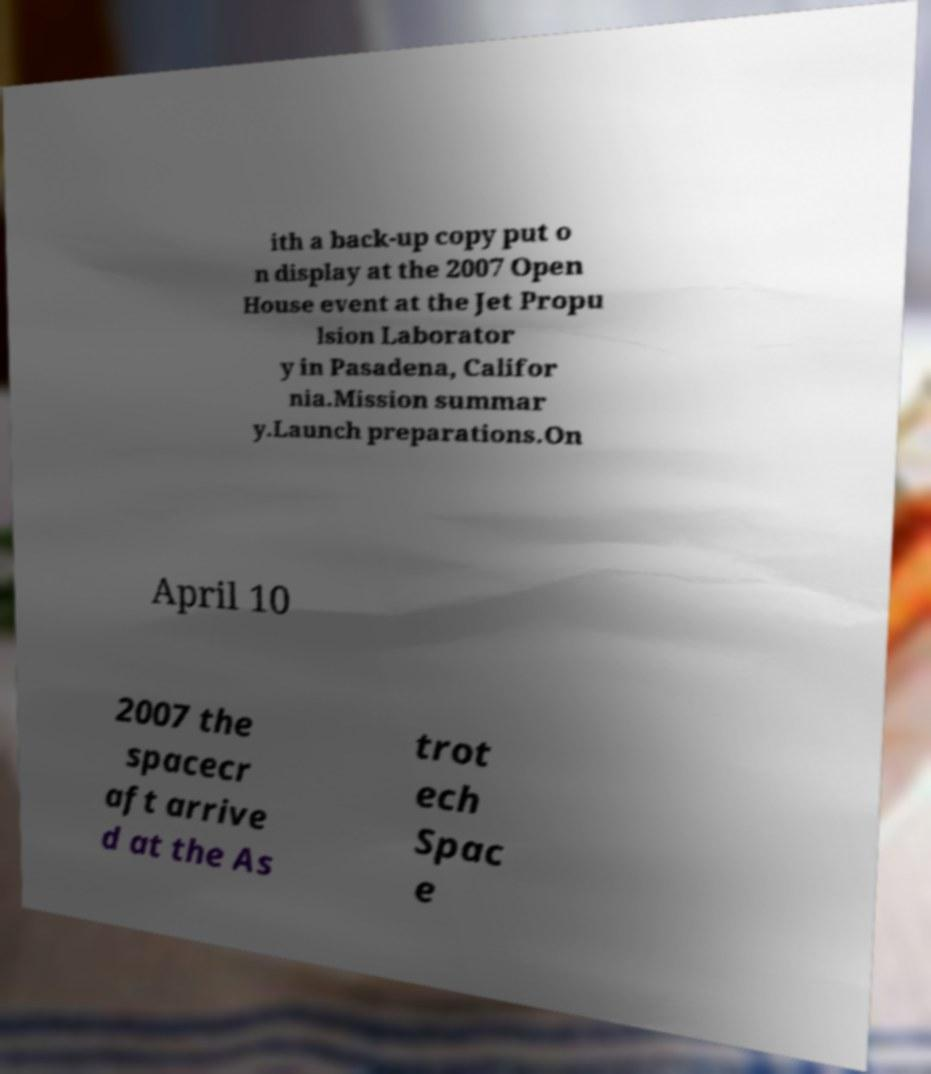Could you extract and type out the text from this image? ith a back-up copy put o n display at the 2007 Open House event at the Jet Propu lsion Laborator y in Pasadena, Califor nia.Mission summar y.Launch preparations.On April 10 2007 the spacecr aft arrive d at the As trot ech Spac e 